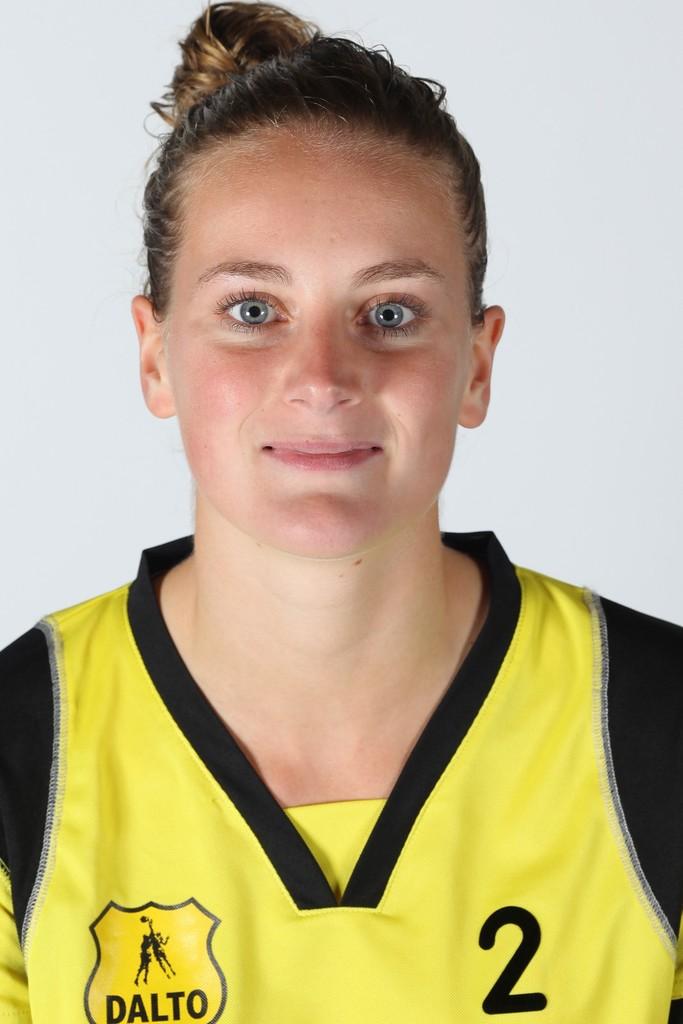What team does the girl belong to?
Ensure brevity in your answer.  Dalto. What number is this player?
Provide a succinct answer. 2. 